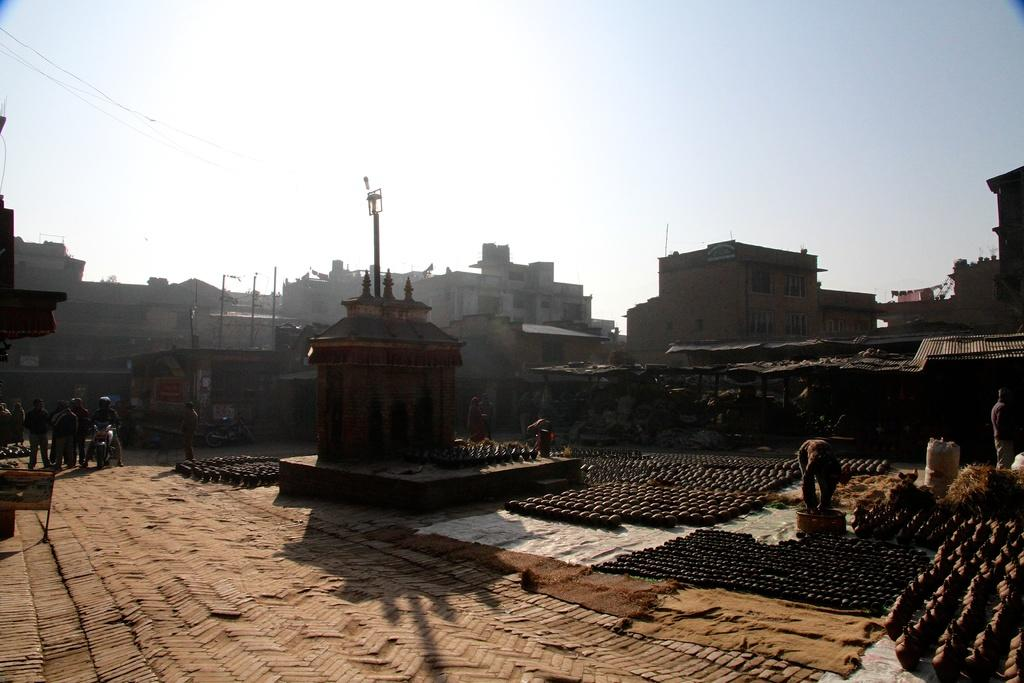What type of objects can be seen in the image that are made with soil? There are objects made with soil in the image. Can you describe the people in the image? There are they doing any activities? What types of structures are visible in the image? Houses, stores, buildings, and sheds are visible in the image. Are there any vehicles in the image? Yes, vehicles are visible in the image. What else can be seen in the image besides the structures and vehicles? Poles, wires, and the sky are visible in the image. Where is the sink located in the image? There is no sink present in the image. Is there a club visible in the image? There is no club visible in the image. Can you see a bear in the image? There is no bear present in the image. 